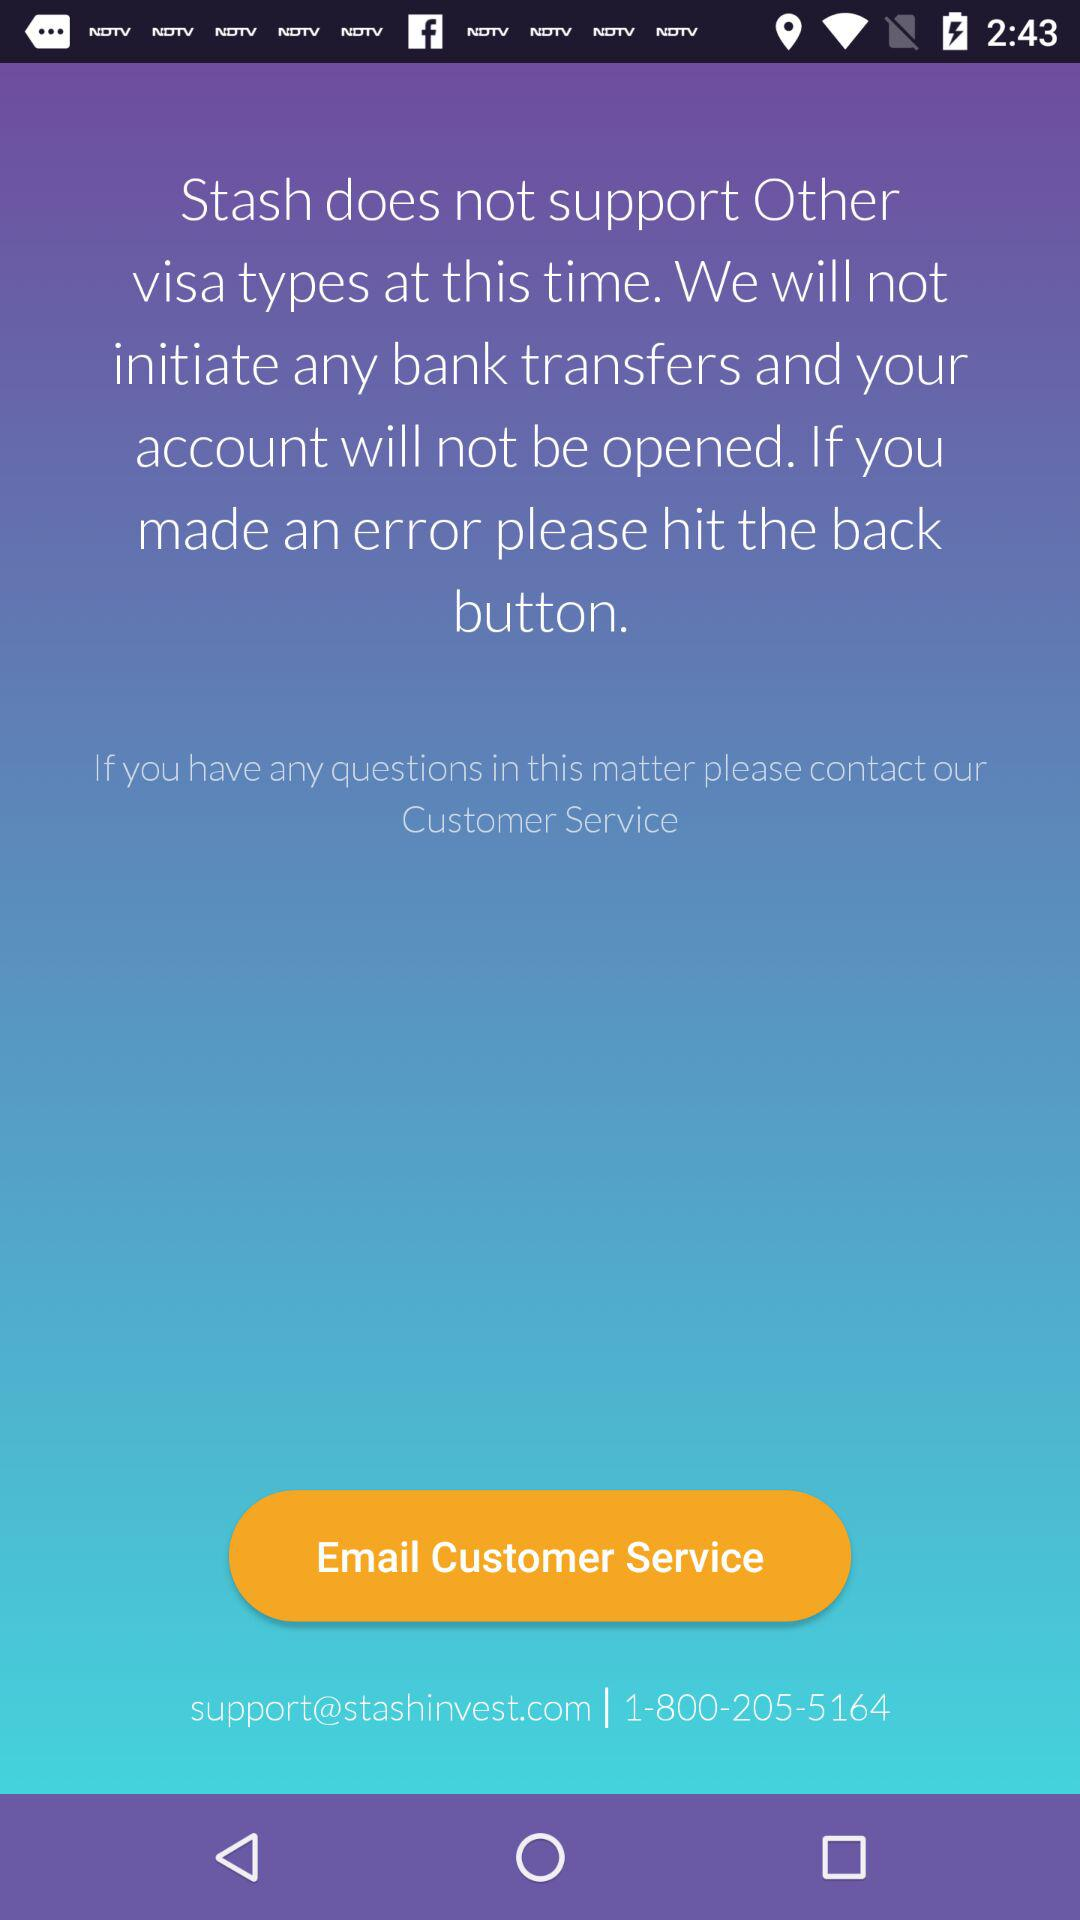What is the customer support number? The customer support number is 1-800-205-5164. 